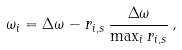Convert formula to latex. <formula><loc_0><loc_0><loc_500><loc_500>\omega _ { i } = \Delta \omega - r _ { i , s } \, \frac { \Delta \omega } { \max _ { i } { r _ { i , s } } } \, ,</formula> 